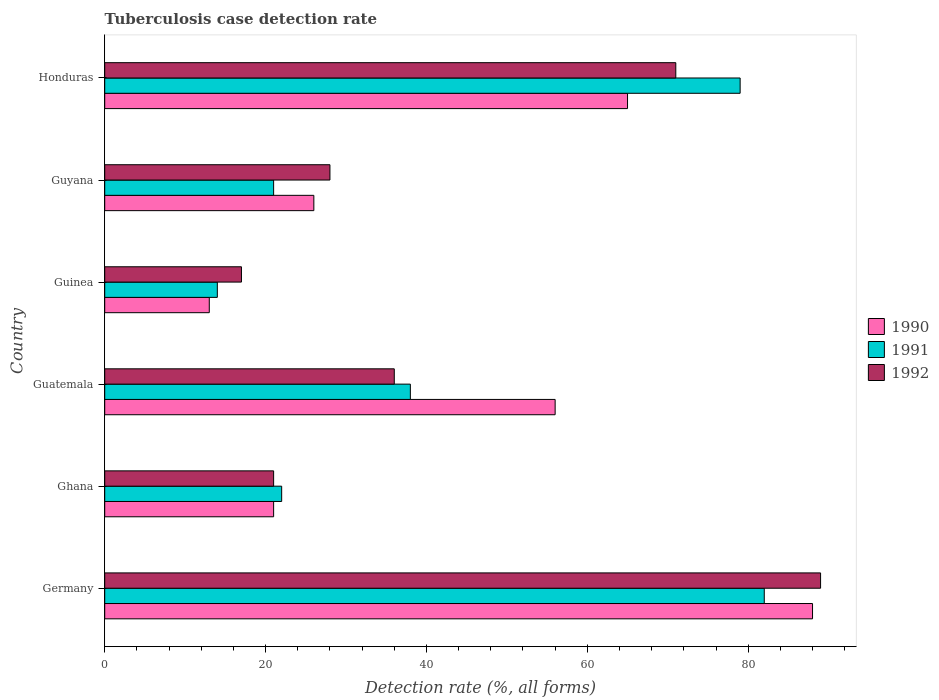How many groups of bars are there?
Your answer should be very brief. 6. Are the number of bars per tick equal to the number of legend labels?
Give a very brief answer. Yes. How many bars are there on the 5th tick from the top?
Give a very brief answer. 3. How many bars are there on the 4th tick from the bottom?
Provide a short and direct response. 3. Across all countries, what is the minimum tuberculosis case detection rate in in 1992?
Give a very brief answer. 17. In which country was the tuberculosis case detection rate in in 1991 maximum?
Your answer should be compact. Germany. In which country was the tuberculosis case detection rate in in 1990 minimum?
Your answer should be compact. Guinea. What is the total tuberculosis case detection rate in in 1990 in the graph?
Keep it short and to the point. 269. What is the average tuberculosis case detection rate in in 1990 per country?
Offer a very short reply. 44.83. What is the ratio of the tuberculosis case detection rate in in 1991 in Germany to that in Guatemala?
Offer a terse response. 2.16. Is the difference between the tuberculosis case detection rate in in 1990 in Guatemala and Guyana greater than the difference between the tuberculosis case detection rate in in 1992 in Guatemala and Guyana?
Give a very brief answer. Yes. What is the difference between the highest and the second highest tuberculosis case detection rate in in 1990?
Offer a terse response. 23. In how many countries, is the tuberculosis case detection rate in in 1992 greater than the average tuberculosis case detection rate in in 1992 taken over all countries?
Make the answer very short. 2. Are all the bars in the graph horizontal?
Your answer should be very brief. Yes. What is the difference between two consecutive major ticks on the X-axis?
Offer a terse response. 20. Are the values on the major ticks of X-axis written in scientific E-notation?
Ensure brevity in your answer.  No. Does the graph contain any zero values?
Provide a succinct answer. No. How are the legend labels stacked?
Make the answer very short. Vertical. What is the title of the graph?
Your response must be concise. Tuberculosis case detection rate. What is the label or title of the X-axis?
Make the answer very short. Detection rate (%, all forms). What is the Detection rate (%, all forms) in 1991 in Germany?
Offer a very short reply. 82. What is the Detection rate (%, all forms) of 1992 in Germany?
Provide a succinct answer. 89. What is the Detection rate (%, all forms) in 1990 in Ghana?
Your answer should be very brief. 21. What is the Detection rate (%, all forms) of 1991 in Ghana?
Give a very brief answer. 22. What is the Detection rate (%, all forms) of 1992 in Ghana?
Your response must be concise. 21. What is the Detection rate (%, all forms) of 1990 in Guatemala?
Your answer should be compact. 56. What is the Detection rate (%, all forms) of 1991 in Guinea?
Your answer should be very brief. 14. What is the Detection rate (%, all forms) of 1992 in Guinea?
Give a very brief answer. 17. What is the Detection rate (%, all forms) of 1990 in Honduras?
Your response must be concise. 65. What is the Detection rate (%, all forms) of 1991 in Honduras?
Your answer should be compact. 79. Across all countries, what is the maximum Detection rate (%, all forms) of 1990?
Your response must be concise. 88. Across all countries, what is the maximum Detection rate (%, all forms) in 1991?
Offer a very short reply. 82. Across all countries, what is the maximum Detection rate (%, all forms) in 1992?
Offer a very short reply. 89. Across all countries, what is the minimum Detection rate (%, all forms) of 1990?
Your response must be concise. 13. Across all countries, what is the minimum Detection rate (%, all forms) of 1991?
Give a very brief answer. 14. Across all countries, what is the minimum Detection rate (%, all forms) in 1992?
Offer a very short reply. 17. What is the total Detection rate (%, all forms) in 1990 in the graph?
Offer a terse response. 269. What is the total Detection rate (%, all forms) in 1991 in the graph?
Your answer should be very brief. 256. What is the total Detection rate (%, all forms) in 1992 in the graph?
Ensure brevity in your answer.  262. What is the difference between the Detection rate (%, all forms) of 1990 in Germany and that in Ghana?
Your answer should be very brief. 67. What is the difference between the Detection rate (%, all forms) of 1991 in Germany and that in Ghana?
Offer a very short reply. 60. What is the difference between the Detection rate (%, all forms) of 1992 in Germany and that in Ghana?
Offer a very short reply. 68. What is the difference between the Detection rate (%, all forms) of 1991 in Germany and that in Guatemala?
Provide a succinct answer. 44. What is the difference between the Detection rate (%, all forms) in 1992 in Germany and that in Guatemala?
Offer a very short reply. 53. What is the difference between the Detection rate (%, all forms) in 1991 in Germany and that in Guinea?
Ensure brevity in your answer.  68. What is the difference between the Detection rate (%, all forms) in 1990 in Germany and that in Guyana?
Keep it short and to the point. 62. What is the difference between the Detection rate (%, all forms) in 1991 in Germany and that in Guyana?
Your response must be concise. 61. What is the difference between the Detection rate (%, all forms) in 1990 in Germany and that in Honduras?
Give a very brief answer. 23. What is the difference between the Detection rate (%, all forms) of 1992 in Germany and that in Honduras?
Provide a short and direct response. 18. What is the difference between the Detection rate (%, all forms) in 1990 in Ghana and that in Guatemala?
Your response must be concise. -35. What is the difference between the Detection rate (%, all forms) of 1990 in Ghana and that in Guinea?
Offer a very short reply. 8. What is the difference between the Detection rate (%, all forms) of 1991 in Ghana and that in Guinea?
Offer a terse response. 8. What is the difference between the Detection rate (%, all forms) in 1990 in Ghana and that in Guyana?
Your answer should be very brief. -5. What is the difference between the Detection rate (%, all forms) in 1991 in Ghana and that in Guyana?
Ensure brevity in your answer.  1. What is the difference between the Detection rate (%, all forms) in 1992 in Ghana and that in Guyana?
Make the answer very short. -7. What is the difference between the Detection rate (%, all forms) of 1990 in Ghana and that in Honduras?
Provide a short and direct response. -44. What is the difference between the Detection rate (%, all forms) of 1991 in Ghana and that in Honduras?
Provide a succinct answer. -57. What is the difference between the Detection rate (%, all forms) of 1990 in Guatemala and that in Guinea?
Offer a terse response. 43. What is the difference between the Detection rate (%, all forms) of 1991 in Guatemala and that in Guinea?
Your response must be concise. 24. What is the difference between the Detection rate (%, all forms) of 1992 in Guatemala and that in Guinea?
Provide a succinct answer. 19. What is the difference between the Detection rate (%, all forms) in 1990 in Guatemala and that in Guyana?
Your response must be concise. 30. What is the difference between the Detection rate (%, all forms) in 1991 in Guatemala and that in Guyana?
Offer a terse response. 17. What is the difference between the Detection rate (%, all forms) in 1992 in Guatemala and that in Guyana?
Offer a very short reply. 8. What is the difference between the Detection rate (%, all forms) of 1990 in Guatemala and that in Honduras?
Provide a succinct answer. -9. What is the difference between the Detection rate (%, all forms) in 1991 in Guatemala and that in Honduras?
Your answer should be very brief. -41. What is the difference between the Detection rate (%, all forms) of 1992 in Guatemala and that in Honduras?
Your answer should be compact. -35. What is the difference between the Detection rate (%, all forms) in 1990 in Guinea and that in Honduras?
Offer a very short reply. -52. What is the difference between the Detection rate (%, all forms) in 1991 in Guinea and that in Honduras?
Provide a succinct answer. -65. What is the difference between the Detection rate (%, all forms) in 1992 in Guinea and that in Honduras?
Offer a very short reply. -54. What is the difference between the Detection rate (%, all forms) of 1990 in Guyana and that in Honduras?
Provide a succinct answer. -39. What is the difference between the Detection rate (%, all forms) of 1991 in Guyana and that in Honduras?
Provide a short and direct response. -58. What is the difference between the Detection rate (%, all forms) in 1992 in Guyana and that in Honduras?
Your answer should be compact. -43. What is the difference between the Detection rate (%, all forms) of 1990 in Germany and the Detection rate (%, all forms) of 1991 in Ghana?
Keep it short and to the point. 66. What is the difference between the Detection rate (%, all forms) of 1990 in Germany and the Detection rate (%, all forms) of 1991 in Guatemala?
Your answer should be very brief. 50. What is the difference between the Detection rate (%, all forms) in 1990 in Germany and the Detection rate (%, all forms) in 1992 in Guatemala?
Provide a succinct answer. 52. What is the difference between the Detection rate (%, all forms) in 1991 in Germany and the Detection rate (%, all forms) in 1992 in Guatemala?
Give a very brief answer. 46. What is the difference between the Detection rate (%, all forms) in 1990 in Germany and the Detection rate (%, all forms) in 1991 in Guinea?
Your response must be concise. 74. What is the difference between the Detection rate (%, all forms) of 1990 in Germany and the Detection rate (%, all forms) of 1992 in Guinea?
Provide a succinct answer. 71. What is the difference between the Detection rate (%, all forms) in 1990 in Germany and the Detection rate (%, all forms) in 1991 in Guyana?
Offer a very short reply. 67. What is the difference between the Detection rate (%, all forms) of 1990 in Germany and the Detection rate (%, all forms) of 1992 in Guyana?
Keep it short and to the point. 60. What is the difference between the Detection rate (%, all forms) of 1991 in Germany and the Detection rate (%, all forms) of 1992 in Honduras?
Give a very brief answer. 11. What is the difference between the Detection rate (%, all forms) of 1991 in Ghana and the Detection rate (%, all forms) of 1992 in Guatemala?
Provide a short and direct response. -14. What is the difference between the Detection rate (%, all forms) in 1991 in Ghana and the Detection rate (%, all forms) in 1992 in Guinea?
Offer a very short reply. 5. What is the difference between the Detection rate (%, all forms) in 1990 in Ghana and the Detection rate (%, all forms) in 1991 in Guyana?
Offer a very short reply. 0. What is the difference between the Detection rate (%, all forms) of 1990 in Ghana and the Detection rate (%, all forms) of 1991 in Honduras?
Give a very brief answer. -58. What is the difference between the Detection rate (%, all forms) of 1991 in Ghana and the Detection rate (%, all forms) of 1992 in Honduras?
Provide a short and direct response. -49. What is the difference between the Detection rate (%, all forms) of 1990 in Guatemala and the Detection rate (%, all forms) of 1991 in Guinea?
Keep it short and to the point. 42. What is the difference between the Detection rate (%, all forms) of 1990 in Guatemala and the Detection rate (%, all forms) of 1992 in Guinea?
Make the answer very short. 39. What is the difference between the Detection rate (%, all forms) of 1991 in Guatemala and the Detection rate (%, all forms) of 1992 in Guinea?
Keep it short and to the point. 21. What is the difference between the Detection rate (%, all forms) in 1990 in Guatemala and the Detection rate (%, all forms) in 1991 in Guyana?
Ensure brevity in your answer.  35. What is the difference between the Detection rate (%, all forms) in 1990 in Guatemala and the Detection rate (%, all forms) in 1992 in Guyana?
Keep it short and to the point. 28. What is the difference between the Detection rate (%, all forms) of 1991 in Guatemala and the Detection rate (%, all forms) of 1992 in Guyana?
Offer a terse response. 10. What is the difference between the Detection rate (%, all forms) in 1990 in Guatemala and the Detection rate (%, all forms) in 1991 in Honduras?
Give a very brief answer. -23. What is the difference between the Detection rate (%, all forms) of 1990 in Guatemala and the Detection rate (%, all forms) of 1992 in Honduras?
Make the answer very short. -15. What is the difference between the Detection rate (%, all forms) in 1991 in Guatemala and the Detection rate (%, all forms) in 1992 in Honduras?
Provide a short and direct response. -33. What is the difference between the Detection rate (%, all forms) of 1991 in Guinea and the Detection rate (%, all forms) of 1992 in Guyana?
Provide a succinct answer. -14. What is the difference between the Detection rate (%, all forms) of 1990 in Guinea and the Detection rate (%, all forms) of 1991 in Honduras?
Offer a very short reply. -66. What is the difference between the Detection rate (%, all forms) in 1990 in Guinea and the Detection rate (%, all forms) in 1992 in Honduras?
Your answer should be compact. -58. What is the difference between the Detection rate (%, all forms) in 1991 in Guinea and the Detection rate (%, all forms) in 1992 in Honduras?
Make the answer very short. -57. What is the difference between the Detection rate (%, all forms) in 1990 in Guyana and the Detection rate (%, all forms) in 1991 in Honduras?
Your answer should be very brief. -53. What is the difference between the Detection rate (%, all forms) in 1990 in Guyana and the Detection rate (%, all forms) in 1992 in Honduras?
Give a very brief answer. -45. What is the difference between the Detection rate (%, all forms) of 1991 in Guyana and the Detection rate (%, all forms) of 1992 in Honduras?
Provide a succinct answer. -50. What is the average Detection rate (%, all forms) of 1990 per country?
Your answer should be compact. 44.83. What is the average Detection rate (%, all forms) of 1991 per country?
Keep it short and to the point. 42.67. What is the average Detection rate (%, all forms) of 1992 per country?
Make the answer very short. 43.67. What is the difference between the Detection rate (%, all forms) in 1990 and Detection rate (%, all forms) in 1991 in Germany?
Ensure brevity in your answer.  6. What is the difference between the Detection rate (%, all forms) in 1990 and Detection rate (%, all forms) in 1991 in Ghana?
Offer a very short reply. -1. What is the difference between the Detection rate (%, all forms) in 1991 and Detection rate (%, all forms) in 1992 in Ghana?
Provide a succinct answer. 1. What is the difference between the Detection rate (%, all forms) of 1991 and Detection rate (%, all forms) of 1992 in Guatemala?
Provide a short and direct response. 2. What is the difference between the Detection rate (%, all forms) in 1990 and Detection rate (%, all forms) in 1991 in Guinea?
Give a very brief answer. -1. What is the difference between the Detection rate (%, all forms) in 1990 and Detection rate (%, all forms) in 1992 in Guinea?
Make the answer very short. -4. What is the difference between the Detection rate (%, all forms) of 1991 and Detection rate (%, all forms) of 1992 in Guinea?
Your response must be concise. -3. What is the difference between the Detection rate (%, all forms) in 1991 and Detection rate (%, all forms) in 1992 in Guyana?
Provide a succinct answer. -7. What is the difference between the Detection rate (%, all forms) in 1990 and Detection rate (%, all forms) in 1991 in Honduras?
Provide a succinct answer. -14. What is the ratio of the Detection rate (%, all forms) in 1990 in Germany to that in Ghana?
Your answer should be very brief. 4.19. What is the ratio of the Detection rate (%, all forms) of 1991 in Germany to that in Ghana?
Offer a very short reply. 3.73. What is the ratio of the Detection rate (%, all forms) of 1992 in Germany to that in Ghana?
Ensure brevity in your answer.  4.24. What is the ratio of the Detection rate (%, all forms) of 1990 in Germany to that in Guatemala?
Provide a succinct answer. 1.57. What is the ratio of the Detection rate (%, all forms) of 1991 in Germany to that in Guatemala?
Offer a terse response. 2.16. What is the ratio of the Detection rate (%, all forms) of 1992 in Germany to that in Guatemala?
Make the answer very short. 2.47. What is the ratio of the Detection rate (%, all forms) of 1990 in Germany to that in Guinea?
Provide a short and direct response. 6.77. What is the ratio of the Detection rate (%, all forms) of 1991 in Germany to that in Guinea?
Give a very brief answer. 5.86. What is the ratio of the Detection rate (%, all forms) in 1992 in Germany to that in Guinea?
Your response must be concise. 5.24. What is the ratio of the Detection rate (%, all forms) of 1990 in Germany to that in Guyana?
Make the answer very short. 3.38. What is the ratio of the Detection rate (%, all forms) of 1991 in Germany to that in Guyana?
Make the answer very short. 3.9. What is the ratio of the Detection rate (%, all forms) of 1992 in Germany to that in Guyana?
Your response must be concise. 3.18. What is the ratio of the Detection rate (%, all forms) of 1990 in Germany to that in Honduras?
Make the answer very short. 1.35. What is the ratio of the Detection rate (%, all forms) in 1991 in Germany to that in Honduras?
Offer a very short reply. 1.04. What is the ratio of the Detection rate (%, all forms) in 1992 in Germany to that in Honduras?
Offer a terse response. 1.25. What is the ratio of the Detection rate (%, all forms) of 1991 in Ghana to that in Guatemala?
Offer a terse response. 0.58. What is the ratio of the Detection rate (%, all forms) in 1992 in Ghana to that in Guatemala?
Offer a terse response. 0.58. What is the ratio of the Detection rate (%, all forms) of 1990 in Ghana to that in Guinea?
Offer a very short reply. 1.62. What is the ratio of the Detection rate (%, all forms) of 1991 in Ghana to that in Guinea?
Keep it short and to the point. 1.57. What is the ratio of the Detection rate (%, all forms) in 1992 in Ghana to that in Guinea?
Make the answer very short. 1.24. What is the ratio of the Detection rate (%, all forms) of 1990 in Ghana to that in Guyana?
Offer a very short reply. 0.81. What is the ratio of the Detection rate (%, all forms) of 1991 in Ghana to that in Guyana?
Your response must be concise. 1.05. What is the ratio of the Detection rate (%, all forms) of 1992 in Ghana to that in Guyana?
Provide a succinct answer. 0.75. What is the ratio of the Detection rate (%, all forms) of 1990 in Ghana to that in Honduras?
Provide a succinct answer. 0.32. What is the ratio of the Detection rate (%, all forms) in 1991 in Ghana to that in Honduras?
Your response must be concise. 0.28. What is the ratio of the Detection rate (%, all forms) of 1992 in Ghana to that in Honduras?
Make the answer very short. 0.3. What is the ratio of the Detection rate (%, all forms) in 1990 in Guatemala to that in Guinea?
Provide a succinct answer. 4.31. What is the ratio of the Detection rate (%, all forms) in 1991 in Guatemala to that in Guinea?
Provide a short and direct response. 2.71. What is the ratio of the Detection rate (%, all forms) in 1992 in Guatemala to that in Guinea?
Make the answer very short. 2.12. What is the ratio of the Detection rate (%, all forms) in 1990 in Guatemala to that in Guyana?
Provide a short and direct response. 2.15. What is the ratio of the Detection rate (%, all forms) of 1991 in Guatemala to that in Guyana?
Your answer should be compact. 1.81. What is the ratio of the Detection rate (%, all forms) of 1992 in Guatemala to that in Guyana?
Make the answer very short. 1.29. What is the ratio of the Detection rate (%, all forms) of 1990 in Guatemala to that in Honduras?
Offer a very short reply. 0.86. What is the ratio of the Detection rate (%, all forms) in 1991 in Guatemala to that in Honduras?
Offer a terse response. 0.48. What is the ratio of the Detection rate (%, all forms) of 1992 in Guatemala to that in Honduras?
Offer a terse response. 0.51. What is the ratio of the Detection rate (%, all forms) in 1990 in Guinea to that in Guyana?
Keep it short and to the point. 0.5. What is the ratio of the Detection rate (%, all forms) of 1991 in Guinea to that in Guyana?
Your answer should be very brief. 0.67. What is the ratio of the Detection rate (%, all forms) in 1992 in Guinea to that in Guyana?
Your answer should be very brief. 0.61. What is the ratio of the Detection rate (%, all forms) of 1991 in Guinea to that in Honduras?
Your response must be concise. 0.18. What is the ratio of the Detection rate (%, all forms) of 1992 in Guinea to that in Honduras?
Give a very brief answer. 0.24. What is the ratio of the Detection rate (%, all forms) of 1991 in Guyana to that in Honduras?
Keep it short and to the point. 0.27. What is the ratio of the Detection rate (%, all forms) of 1992 in Guyana to that in Honduras?
Offer a terse response. 0.39. What is the difference between the highest and the second highest Detection rate (%, all forms) of 1991?
Offer a terse response. 3. 